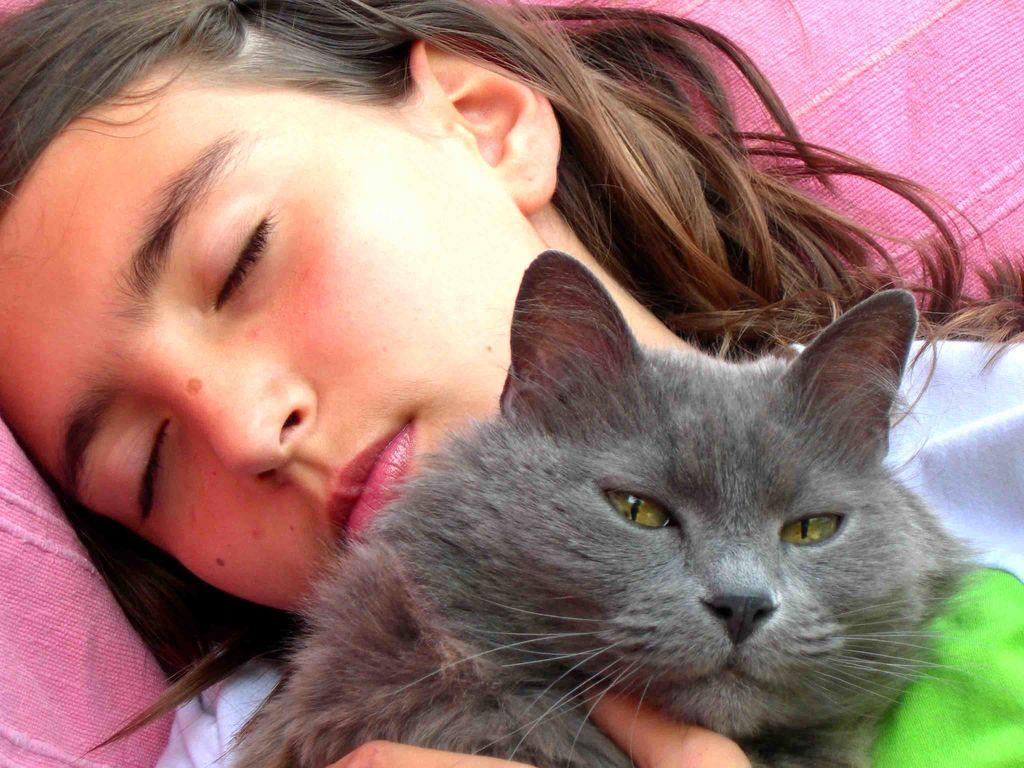Who is the main subject in the image? There is a lady in the image. What is the lady wearing? The lady is wearing a white and green t-shirt. What is the lady doing in the image? The lady is sleeping. What is the lady holding in her hand? The lady is holding a black cat in her hand. What color is the cloth visible in the background of the image? There is a pink cloth in the background of the image. What type of voyage is the lady planning to embark on in the image? There is no indication of a voyage in the image; the lady is sleeping and holding a black cat. What activity is the lady participating in with the top in the image? There is no top or any activity involving a top mentioned or visible in the image. 